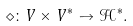<formula> <loc_0><loc_0><loc_500><loc_500>\diamond \colon V \times V ^ { \ast } \to \mathcal { H } ^ { \ast } .</formula> 